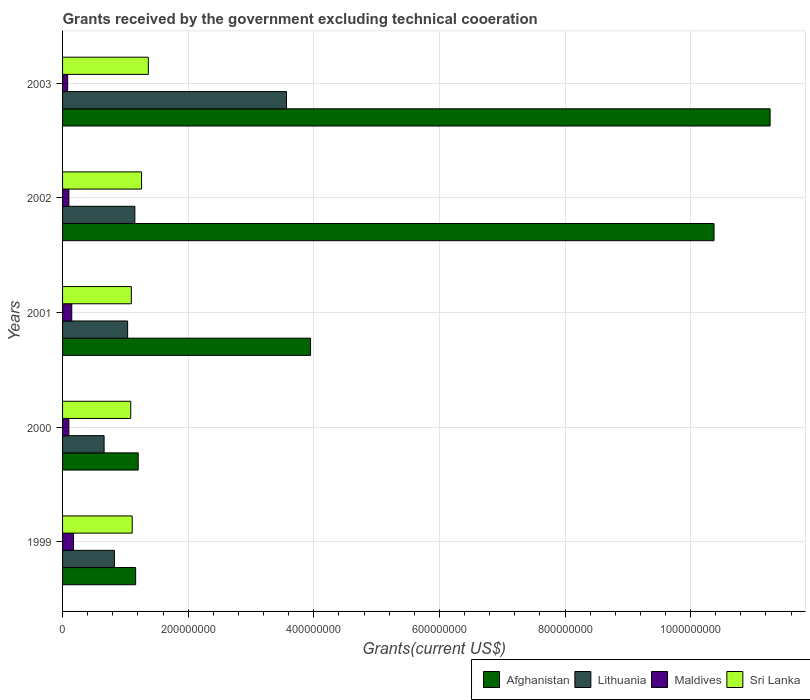Are the number of bars per tick equal to the number of legend labels?
Your response must be concise. Yes. How many bars are there on the 4th tick from the top?
Your response must be concise. 4. How many bars are there on the 3rd tick from the bottom?
Provide a succinct answer. 4. What is the label of the 1st group of bars from the top?
Your answer should be compact. 2003. In how many cases, is the number of bars for a given year not equal to the number of legend labels?
Offer a terse response. 0. What is the total grants received by the government in Sri Lanka in 2003?
Keep it short and to the point. 1.37e+08. Across all years, what is the maximum total grants received by the government in Sri Lanka?
Give a very brief answer. 1.37e+08. Across all years, what is the minimum total grants received by the government in Afghanistan?
Keep it short and to the point. 1.16e+08. What is the total total grants received by the government in Afghanistan in the graph?
Provide a succinct answer. 2.80e+09. What is the difference between the total grants received by the government in Sri Lanka in 2000 and that in 2003?
Ensure brevity in your answer.  -2.80e+07. What is the difference between the total grants received by the government in Lithuania in 2001 and the total grants received by the government in Maldives in 2002?
Keep it short and to the point. 9.35e+07. What is the average total grants received by the government in Maldives per year?
Provide a succinct answer. 1.21e+07. In the year 2003, what is the difference between the total grants received by the government in Sri Lanka and total grants received by the government in Maldives?
Keep it short and to the point. 1.28e+08. What is the ratio of the total grants received by the government in Sri Lanka in 1999 to that in 2002?
Keep it short and to the point. 0.88. What is the difference between the highest and the second highest total grants received by the government in Lithuania?
Keep it short and to the point. 2.41e+08. What is the difference between the highest and the lowest total grants received by the government in Maldives?
Your answer should be very brief. 9.37e+06. Is it the case that in every year, the sum of the total grants received by the government in Maldives and total grants received by the government in Sri Lanka is greater than the sum of total grants received by the government in Lithuania and total grants received by the government in Afghanistan?
Your answer should be very brief. Yes. What does the 4th bar from the top in 2001 represents?
Offer a terse response. Afghanistan. What does the 3rd bar from the bottom in 2003 represents?
Your response must be concise. Maldives. Is it the case that in every year, the sum of the total grants received by the government in Sri Lanka and total grants received by the government in Maldives is greater than the total grants received by the government in Afghanistan?
Offer a terse response. No. Are all the bars in the graph horizontal?
Offer a terse response. Yes. How many years are there in the graph?
Offer a terse response. 5. Are the values on the major ticks of X-axis written in scientific E-notation?
Your response must be concise. No. How are the legend labels stacked?
Provide a short and direct response. Horizontal. What is the title of the graph?
Ensure brevity in your answer.  Grants received by the government excluding technical cooeration. Does "Angola" appear as one of the legend labels in the graph?
Provide a short and direct response. No. What is the label or title of the X-axis?
Keep it short and to the point. Grants(current US$). What is the Grants(current US$) of Afghanistan in 1999?
Keep it short and to the point. 1.16e+08. What is the Grants(current US$) in Lithuania in 1999?
Ensure brevity in your answer.  8.26e+07. What is the Grants(current US$) of Maldives in 1999?
Offer a very short reply. 1.75e+07. What is the Grants(current US$) in Sri Lanka in 1999?
Keep it short and to the point. 1.11e+08. What is the Grants(current US$) in Afghanistan in 2000?
Keep it short and to the point. 1.20e+08. What is the Grants(current US$) of Lithuania in 2000?
Give a very brief answer. 6.61e+07. What is the Grants(current US$) of Maldives in 2000?
Make the answer very short. 1.00e+07. What is the Grants(current US$) in Sri Lanka in 2000?
Offer a terse response. 1.09e+08. What is the Grants(current US$) in Afghanistan in 2001?
Offer a very short reply. 3.95e+08. What is the Grants(current US$) of Lithuania in 2001?
Your answer should be compact. 1.04e+08. What is the Grants(current US$) of Maldives in 2001?
Your response must be concise. 1.46e+07. What is the Grants(current US$) in Sri Lanka in 2001?
Give a very brief answer. 1.10e+08. What is the Grants(current US$) of Afghanistan in 2002?
Provide a short and direct response. 1.04e+09. What is the Grants(current US$) in Lithuania in 2002?
Give a very brief answer. 1.15e+08. What is the Grants(current US$) of Maldives in 2002?
Your answer should be compact. 1.01e+07. What is the Grants(current US$) in Sri Lanka in 2002?
Ensure brevity in your answer.  1.26e+08. What is the Grants(current US$) in Afghanistan in 2003?
Offer a terse response. 1.13e+09. What is the Grants(current US$) in Lithuania in 2003?
Give a very brief answer. 3.57e+08. What is the Grants(current US$) in Maldives in 2003?
Offer a terse response. 8.10e+06. What is the Grants(current US$) in Sri Lanka in 2003?
Provide a short and direct response. 1.37e+08. Across all years, what is the maximum Grants(current US$) of Afghanistan?
Provide a short and direct response. 1.13e+09. Across all years, what is the maximum Grants(current US$) of Lithuania?
Your response must be concise. 3.57e+08. Across all years, what is the maximum Grants(current US$) in Maldives?
Your response must be concise. 1.75e+07. Across all years, what is the maximum Grants(current US$) in Sri Lanka?
Provide a succinct answer. 1.37e+08. Across all years, what is the minimum Grants(current US$) of Afghanistan?
Make the answer very short. 1.16e+08. Across all years, what is the minimum Grants(current US$) in Lithuania?
Make the answer very short. 6.61e+07. Across all years, what is the minimum Grants(current US$) of Maldives?
Offer a terse response. 8.10e+06. Across all years, what is the minimum Grants(current US$) of Sri Lanka?
Keep it short and to the point. 1.09e+08. What is the total Grants(current US$) of Afghanistan in the graph?
Offer a very short reply. 2.80e+09. What is the total Grants(current US$) of Lithuania in the graph?
Offer a very short reply. 7.24e+08. What is the total Grants(current US$) in Maldives in the graph?
Keep it short and to the point. 6.03e+07. What is the total Grants(current US$) in Sri Lanka in the graph?
Provide a succinct answer. 5.91e+08. What is the difference between the Grants(current US$) of Afghanistan in 1999 and that in 2000?
Make the answer very short. -4.05e+06. What is the difference between the Grants(current US$) of Lithuania in 1999 and that in 2000?
Your answer should be compact. 1.65e+07. What is the difference between the Grants(current US$) of Maldives in 1999 and that in 2000?
Provide a short and direct response. 7.45e+06. What is the difference between the Grants(current US$) in Sri Lanka in 1999 and that in 2000?
Give a very brief answer. 2.37e+06. What is the difference between the Grants(current US$) of Afghanistan in 1999 and that in 2001?
Offer a terse response. -2.78e+08. What is the difference between the Grants(current US$) of Lithuania in 1999 and that in 2001?
Provide a short and direct response. -2.10e+07. What is the difference between the Grants(current US$) in Maldives in 1999 and that in 2001?
Keep it short and to the point. 2.83e+06. What is the difference between the Grants(current US$) in Sri Lanka in 1999 and that in 2001?
Your answer should be compact. 1.39e+06. What is the difference between the Grants(current US$) of Afghanistan in 1999 and that in 2002?
Keep it short and to the point. -9.21e+08. What is the difference between the Grants(current US$) of Lithuania in 1999 and that in 2002?
Your answer should be very brief. -3.25e+07. What is the difference between the Grants(current US$) of Maldives in 1999 and that in 2002?
Keep it short and to the point. 7.39e+06. What is the difference between the Grants(current US$) of Sri Lanka in 1999 and that in 2002?
Provide a short and direct response. -1.49e+07. What is the difference between the Grants(current US$) in Afghanistan in 1999 and that in 2003?
Your response must be concise. -1.01e+09. What is the difference between the Grants(current US$) in Lithuania in 1999 and that in 2003?
Keep it short and to the point. -2.74e+08. What is the difference between the Grants(current US$) in Maldives in 1999 and that in 2003?
Give a very brief answer. 9.37e+06. What is the difference between the Grants(current US$) of Sri Lanka in 1999 and that in 2003?
Offer a very short reply. -2.56e+07. What is the difference between the Grants(current US$) in Afghanistan in 2000 and that in 2001?
Give a very brief answer. -2.74e+08. What is the difference between the Grants(current US$) in Lithuania in 2000 and that in 2001?
Keep it short and to the point. -3.75e+07. What is the difference between the Grants(current US$) in Maldives in 2000 and that in 2001?
Keep it short and to the point. -4.62e+06. What is the difference between the Grants(current US$) of Sri Lanka in 2000 and that in 2001?
Offer a very short reply. -9.80e+05. What is the difference between the Grants(current US$) in Afghanistan in 2000 and that in 2002?
Your answer should be compact. -9.17e+08. What is the difference between the Grants(current US$) in Lithuania in 2000 and that in 2002?
Your answer should be compact. -4.90e+07. What is the difference between the Grants(current US$) in Sri Lanka in 2000 and that in 2002?
Offer a very short reply. -1.72e+07. What is the difference between the Grants(current US$) in Afghanistan in 2000 and that in 2003?
Ensure brevity in your answer.  -1.01e+09. What is the difference between the Grants(current US$) in Lithuania in 2000 and that in 2003?
Your answer should be compact. -2.90e+08. What is the difference between the Grants(current US$) of Maldives in 2000 and that in 2003?
Keep it short and to the point. 1.92e+06. What is the difference between the Grants(current US$) of Sri Lanka in 2000 and that in 2003?
Ensure brevity in your answer.  -2.80e+07. What is the difference between the Grants(current US$) in Afghanistan in 2001 and that in 2002?
Ensure brevity in your answer.  -6.42e+08. What is the difference between the Grants(current US$) of Lithuania in 2001 and that in 2002?
Make the answer very short. -1.15e+07. What is the difference between the Grants(current US$) in Maldives in 2001 and that in 2002?
Keep it short and to the point. 4.56e+06. What is the difference between the Grants(current US$) in Sri Lanka in 2001 and that in 2002?
Make the answer very short. -1.63e+07. What is the difference between the Grants(current US$) of Afghanistan in 2001 and that in 2003?
Provide a succinct answer. -7.32e+08. What is the difference between the Grants(current US$) of Lithuania in 2001 and that in 2003?
Your answer should be very brief. -2.53e+08. What is the difference between the Grants(current US$) in Maldives in 2001 and that in 2003?
Your answer should be compact. 6.54e+06. What is the difference between the Grants(current US$) in Sri Lanka in 2001 and that in 2003?
Your answer should be very brief. -2.70e+07. What is the difference between the Grants(current US$) in Afghanistan in 2002 and that in 2003?
Offer a very short reply. -8.93e+07. What is the difference between the Grants(current US$) in Lithuania in 2002 and that in 2003?
Make the answer very short. -2.41e+08. What is the difference between the Grants(current US$) in Maldives in 2002 and that in 2003?
Keep it short and to the point. 1.98e+06. What is the difference between the Grants(current US$) in Sri Lanka in 2002 and that in 2003?
Your response must be concise. -1.08e+07. What is the difference between the Grants(current US$) of Afghanistan in 1999 and the Grants(current US$) of Lithuania in 2000?
Your response must be concise. 5.03e+07. What is the difference between the Grants(current US$) of Afghanistan in 1999 and the Grants(current US$) of Maldives in 2000?
Provide a succinct answer. 1.06e+08. What is the difference between the Grants(current US$) of Afghanistan in 1999 and the Grants(current US$) of Sri Lanka in 2000?
Make the answer very short. 7.83e+06. What is the difference between the Grants(current US$) of Lithuania in 1999 and the Grants(current US$) of Maldives in 2000?
Your answer should be very brief. 7.26e+07. What is the difference between the Grants(current US$) in Lithuania in 1999 and the Grants(current US$) in Sri Lanka in 2000?
Your answer should be very brief. -2.60e+07. What is the difference between the Grants(current US$) of Maldives in 1999 and the Grants(current US$) of Sri Lanka in 2000?
Your answer should be compact. -9.11e+07. What is the difference between the Grants(current US$) in Afghanistan in 1999 and the Grants(current US$) in Lithuania in 2001?
Your response must be concise. 1.28e+07. What is the difference between the Grants(current US$) of Afghanistan in 1999 and the Grants(current US$) of Maldives in 2001?
Your answer should be compact. 1.02e+08. What is the difference between the Grants(current US$) of Afghanistan in 1999 and the Grants(current US$) of Sri Lanka in 2001?
Give a very brief answer. 6.85e+06. What is the difference between the Grants(current US$) of Lithuania in 1999 and the Grants(current US$) of Maldives in 2001?
Provide a succinct answer. 6.79e+07. What is the difference between the Grants(current US$) in Lithuania in 1999 and the Grants(current US$) in Sri Lanka in 2001?
Provide a short and direct response. -2.70e+07. What is the difference between the Grants(current US$) of Maldives in 1999 and the Grants(current US$) of Sri Lanka in 2001?
Provide a succinct answer. -9.20e+07. What is the difference between the Grants(current US$) of Afghanistan in 1999 and the Grants(current US$) of Lithuania in 2002?
Keep it short and to the point. 1.28e+06. What is the difference between the Grants(current US$) of Afghanistan in 1999 and the Grants(current US$) of Maldives in 2002?
Your response must be concise. 1.06e+08. What is the difference between the Grants(current US$) of Afghanistan in 1999 and the Grants(current US$) of Sri Lanka in 2002?
Your answer should be compact. -9.41e+06. What is the difference between the Grants(current US$) in Lithuania in 1999 and the Grants(current US$) in Maldives in 2002?
Provide a succinct answer. 7.25e+07. What is the difference between the Grants(current US$) in Lithuania in 1999 and the Grants(current US$) in Sri Lanka in 2002?
Offer a very short reply. -4.32e+07. What is the difference between the Grants(current US$) of Maldives in 1999 and the Grants(current US$) of Sri Lanka in 2002?
Give a very brief answer. -1.08e+08. What is the difference between the Grants(current US$) in Afghanistan in 1999 and the Grants(current US$) in Lithuania in 2003?
Make the answer very short. -2.40e+08. What is the difference between the Grants(current US$) in Afghanistan in 1999 and the Grants(current US$) in Maldives in 2003?
Your answer should be very brief. 1.08e+08. What is the difference between the Grants(current US$) of Afghanistan in 1999 and the Grants(current US$) of Sri Lanka in 2003?
Ensure brevity in your answer.  -2.02e+07. What is the difference between the Grants(current US$) in Lithuania in 1999 and the Grants(current US$) in Maldives in 2003?
Ensure brevity in your answer.  7.45e+07. What is the difference between the Grants(current US$) in Lithuania in 1999 and the Grants(current US$) in Sri Lanka in 2003?
Your response must be concise. -5.40e+07. What is the difference between the Grants(current US$) in Maldives in 1999 and the Grants(current US$) in Sri Lanka in 2003?
Provide a succinct answer. -1.19e+08. What is the difference between the Grants(current US$) in Afghanistan in 2000 and the Grants(current US$) in Lithuania in 2001?
Ensure brevity in your answer.  1.68e+07. What is the difference between the Grants(current US$) of Afghanistan in 2000 and the Grants(current US$) of Maldives in 2001?
Make the answer very short. 1.06e+08. What is the difference between the Grants(current US$) in Afghanistan in 2000 and the Grants(current US$) in Sri Lanka in 2001?
Provide a short and direct response. 1.09e+07. What is the difference between the Grants(current US$) in Lithuania in 2000 and the Grants(current US$) in Maldives in 2001?
Make the answer very short. 5.15e+07. What is the difference between the Grants(current US$) in Lithuania in 2000 and the Grants(current US$) in Sri Lanka in 2001?
Your answer should be very brief. -4.34e+07. What is the difference between the Grants(current US$) in Maldives in 2000 and the Grants(current US$) in Sri Lanka in 2001?
Your response must be concise. -9.95e+07. What is the difference between the Grants(current US$) of Afghanistan in 2000 and the Grants(current US$) of Lithuania in 2002?
Offer a very short reply. 5.33e+06. What is the difference between the Grants(current US$) in Afghanistan in 2000 and the Grants(current US$) in Maldives in 2002?
Provide a succinct answer. 1.10e+08. What is the difference between the Grants(current US$) in Afghanistan in 2000 and the Grants(current US$) in Sri Lanka in 2002?
Provide a short and direct response. -5.36e+06. What is the difference between the Grants(current US$) in Lithuania in 2000 and the Grants(current US$) in Maldives in 2002?
Your answer should be very brief. 5.60e+07. What is the difference between the Grants(current US$) of Lithuania in 2000 and the Grants(current US$) of Sri Lanka in 2002?
Provide a short and direct response. -5.97e+07. What is the difference between the Grants(current US$) in Maldives in 2000 and the Grants(current US$) in Sri Lanka in 2002?
Make the answer very short. -1.16e+08. What is the difference between the Grants(current US$) of Afghanistan in 2000 and the Grants(current US$) of Lithuania in 2003?
Your response must be concise. -2.36e+08. What is the difference between the Grants(current US$) in Afghanistan in 2000 and the Grants(current US$) in Maldives in 2003?
Make the answer very short. 1.12e+08. What is the difference between the Grants(current US$) of Afghanistan in 2000 and the Grants(current US$) of Sri Lanka in 2003?
Ensure brevity in your answer.  -1.61e+07. What is the difference between the Grants(current US$) of Lithuania in 2000 and the Grants(current US$) of Maldives in 2003?
Your answer should be very brief. 5.80e+07. What is the difference between the Grants(current US$) in Lithuania in 2000 and the Grants(current US$) in Sri Lanka in 2003?
Offer a terse response. -7.04e+07. What is the difference between the Grants(current US$) in Maldives in 2000 and the Grants(current US$) in Sri Lanka in 2003?
Provide a short and direct response. -1.27e+08. What is the difference between the Grants(current US$) of Afghanistan in 2001 and the Grants(current US$) of Lithuania in 2002?
Your response must be concise. 2.80e+08. What is the difference between the Grants(current US$) in Afghanistan in 2001 and the Grants(current US$) in Maldives in 2002?
Ensure brevity in your answer.  3.85e+08. What is the difference between the Grants(current US$) in Afghanistan in 2001 and the Grants(current US$) in Sri Lanka in 2002?
Keep it short and to the point. 2.69e+08. What is the difference between the Grants(current US$) in Lithuania in 2001 and the Grants(current US$) in Maldives in 2002?
Ensure brevity in your answer.  9.35e+07. What is the difference between the Grants(current US$) in Lithuania in 2001 and the Grants(current US$) in Sri Lanka in 2002?
Provide a short and direct response. -2.22e+07. What is the difference between the Grants(current US$) in Maldives in 2001 and the Grants(current US$) in Sri Lanka in 2002?
Make the answer very short. -1.11e+08. What is the difference between the Grants(current US$) in Afghanistan in 2001 and the Grants(current US$) in Lithuania in 2003?
Offer a very short reply. 3.83e+07. What is the difference between the Grants(current US$) in Afghanistan in 2001 and the Grants(current US$) in Maldives in 2003?
Offer a terse response. 3.87e+08. What is the difference between the Grants(current US$) in Afghanistan in 2001 and the Grants(current US$) in Sri Lanka in 2003?
Offer a terse response. 2.58e+08. What is the difference between the Grants(current US$) of Lithuania in 2001 and the Grants(current US$) of Maldives in 2003?
Give a very brief answer. 9.55e+07. What is the difference between the Grants(current US$) in Lithuania in 2001 and the Grants(current US$) in Sri Lanka in 2003?
Your answer should be very brief. -3.29e+07. What is the difference between the Grants(current US$) in Maldives in 2001 and the Grants(current US$) in Sri Lanka in 2003?
Offer a very short reply. -1.22e+08. What is the difference between the Grants(current US$) of Afghanistan in 2002 and the Grants(current US$) of Lithuania in 2003?
Your response must be concise. 6.81e+08. What is the difference between the Grants(current US$) in Afghanistan in 2002 and the Grants(current US$) in Maldives in 2003?
Offer a terse response. 1.03e+09. What is the difference between the Grants(current US$) of Afghanistan in 2002 and the Grants(current US$) of Sri Lanka in 2003?
Provide a succinct answer. 9.01e+08. What is the difference between the Grants(current US$) in Lithuania in 2002 and the Grants(current US$) in Maldives in 2003?
Provide a succinct answer. 1.07e+08. What is the difference between the Grants(current US$) in Lithuania in 2002 and the Grants(current US$) in Sri Lanka in 2003?
Your answer should be compact. -2.15e+07. What is the difference between the Grants(current US$) in Maldives in 2002 and the Grants(current US$) in Sri Lanka in 2003?
Give a very brief answer. -1.26e+08. What is the average Grants(current US$) of Afghanistan per year?
Give a very brief answer. 5.59e+08. What is the average Grants(current US$) in Lithuania per year?
Your answer should be compact. 1.45e+08. What is the average Grants(current US$) of Maldives per year?
Make the answer very short. 1.21e+07. What is the average Grants(current US$) in Sri Lanka per year?
Provide a short and direct response. 1.18e+08. In the year 1999, what is the difference between the Grants(current US$) in Afghanistan and Grants(current US$) in Lithuania?
Provide a succinct answer. 3.38e+07. In the year 1999, what is the difference between the Grants(current US$) in Afghanistan and Grants(current US$) in Maldives?
Provide a succinct answer. 9.89e+07. In the year 1999, what is the difference between the Grants(current US$) of Afghanistan and Grants(current US$) of Sri Lanka?
Your answer should be very brief. 5.46e+06. In the year 1999, what is the difference between the Grants(current US$) in Lithuania and Grants(current US$) in Maldives?
Keep it short and to the point. 6.51e+07. In the year 1999, what is the difference between the Grants(current US$) in Lithuania and Grants(current US$) in Sri Lanka?
Make the answer very short. -2.83e+07. In the year 1999, what is the difference between the Grants(current US$) of Maldives and Grants(current US$) of Sri Lanka?
Make the answer very short. -9.34e+07. In the year 2000, what is the difference between the Grants(current US$) in Afghanistan and Grants(current US$) in Lithuania?
Provide a succinct answer. 5.43e+07. In the year 2000, what is the difference between the Grants(current US$) of Afghanistan and Grants(current US$) of Maldives?
Your answer should be compact. 1.10e+08. In the year 2000, what is the difference between the Grants(current US$) in Afghanistan and Grants(current US$) in Sri Lanka?
Offer a terse response. 1.19e+07. In the year 2000, what is the difference between the Grants(current US$) of Lithuania and Grants(current US$) of Maldives?
Your response must be concise. 5.61e+07. In the year 2000, what is the difference between the Grants(current US$) in Lithuania and Grants(current US$) in Sri Lanka?
Make the answer very short. -4.24e+07. In the year 2000, what is the difference between the Grants(current US$) in Maldives and Grants(current US$) in Sri Lanka?
Your response must be concise. -9.85e+07. In the year 2001, what is the difference between the Grants(current US$) of Afghanistan and Grants(current US$) of Lithuania?
Your response must be concise. 2.91e+08. In the year 2001, what is the difference between the Grants(current US$) of Afghanistan and Grants(current US$) of Maldives?
Ensure brevity in your answer.  3.80e+08. In the year 2001, what is the difference between the Grants(current US$) in Afghanistan and Grants(current US$) in Sri Lanka?
Keep it short and to the point. 2.85e+08. In the year 2001, what is the difference between the Grants(current US$) in Lithuania and Grants(current US$) in Maldives?
Give a very brief answer. 8.90e+07. In the year 2001, what is the difference between the Grants(current US$) in Lithuania and Grants(current US$) in Sri Lanka?
Your answer should be compact. -5.90e+06. In the year 2001, what is the difference between the Grants(current US$) of Maldives and Grants(current US$) of Sri Lanka?
Offer a very short reply. -9.49e+07. In the year 2002, what is the difference between the Grants(current US$) in Afghanistan and Grants(current US$) in Lithuania?
Keep it short and to the point. 9.22e+08. In the year 2002, what is the difference between the Grants(current US$) in Afghanistan and Grants(current US$) in Maldives?
Keep it short and to the point. 1.03e+09. In the year 2002, what is the difference between the Grants(current US$) in Afghanistan and Grants(current US$) in Sri Lanka?
Provide a succinct answer. 9.11e+08. In the year 2002, what is the difference between the Grants(current US$) in Lithuania and Grants(current US$) in Maldives?
Your response must be concise. 1.05e+08. In the year 2002, what is the difference between the Grants(current US$) in Lithuania and Grants(current US$) in Sri Lanka?
Make the answer very short. -1.07e+07. In the year 2002, what is the difference between the Grants(current US$) in Maldives and Grants(current US$) in Sri Lanka?
Ensure brevity in your answer.  -1.16e+08. In the year 2003, what is the difference between the Grants(current US$) of Afghanistan and Grants(current US$) of Lithuania?
Your answer should be very brief. 7.70e+08. In the year 2003, what is the difference between the Grants(current US$) of Afghanistan and Grants(current US$) of Maldives?
Make the answer very short. 1.12e+09. In the year 2003, what is the difference between the Grants(current US$) of Afghanistan and Grants(current US$) of Sri Lanka?
Make the answer very short. 9.90e+08. In the year 2003, what is the difference between the Grants(current US$) in Lithuania and Grants(current US$) in Maldives?
Your response must be concise. 3.48e+08. In the year 2003, what is the difference between the Grants(current US$) in Lithuania and Grants(current US$) in Sri Lanka?
Offer a terse response. 2.20e+08. In the year 2003, what is the difference between the Grants(current US$) in Maldives and Grants(current US$) in Sri Lanka?
Provide a short and direct response. -1.28e+08. What is the ratio of the Grants(current US$) in Afghanistan in 1999 to that in 2000?
Keep it short and to the point. 0.97. What is the ratio of the Grants(current US$) of Lithuania in 1999 to that in 2000?
Your answer should be compact. 1.25. What is the ratio of the Grants(current US$) of Maldives in 1999 to that in 2000?
Provide a short and direct response. 1.74. What is the ratio of the Grants(current US$) of Sri Lanka in 1999 to that in 2000?
Provide a succinct answer. 1.02. What is the ratio of the Grants(current US$) in Afghanistan in 1999 to that in 2001?
Ensure brevity in your answer.  0.29. What is the ratio of the Grants(current US$) in Lithuania in 1999 to that in 2001?
Offer a very short reply. 0.8. What is the ratio of the Grants(current US$) of Maldives in 1999 to that in 2001?
Ensure brevity in your answer.  1.19. What is the ratio of the Grants(current US$) in Sri Lanka in 1999 to that in 2001?
Offer a very short reply. 1.01. What is the ratio of the Grants(current US$) in Afghanistan in 1999 to that in 2002?
Give a very brief answer. 0.11. What is the ratio of the Grants(current US$) of Lithuania in 1999 to that in 2002?
Your answer should be very brief. 0.72. What is the ratio of the Grants(current US$) in Maldives in 1999 to that in 2002?
Your answer should be compact. 1.73. What is the ratio of the Grants(current US$) of Sri Lanka in 1999 to that in 2002?
Ensure brevity in your answer.  0.88. What is the ratio of the Grants(current US$) of Afghanistan in 1999 to that in 2003?
Give a very brief answer. 0.1. What is the ratio of the Grants(current US$) in Lithuania in 1999 to that in 2003?
Your answer should be very brief. 0.23. What is the ratio of the Grants(current US$) of Maldives in 1999 to that in 2003?
Offer a terse response. 2.16. What is the ratio of the Grants(current US$) in Sri Lanka in 1999 to that in 2003?
Offer a very short reply. 0.81. What is the ratio of the Grants(current US$) in Afghanistan in 2000 to that in 2001?
Give a very brief answer. 0.3. What is the ratio of the Grants(current US$) in Lithuania in 2000 to that in 2001?
Offer a very short reply. 0.64. What is the ratio of the Grants(current US$) in Maldives in 2000 to that in 2001?
Offer a terse response. 0.68. What is the ratio of the Grants(current US$) of Afghanistan in 2000 to that in 2002?
Provide a succinct answer. 0.12. What is the ratio of the Grants(current US$) in Lithuania in 2000 to that in 2002?
Provide a succinct answer. 0.57. What is the ratio of the Grants(current US$) in Sri Lanka in 2000 to that in 2002?
Your response must be concise. 0.86. What is the ratio of the Grants(current US$) of Afghanistan in 2000 to that in 2003?
Your answer should be very brief. 0.11. What is the ratio of the Grants(current US$) of Lithuania in 2000 to that in 2003?
Provide a short and direct response. 0.19. What is the ratio of the Grants(current US$) of Maldives in 2000 to that in 2003?
Offer a very short reply. 1.24. What is the ratio of the Grants(current US$) of Sri Lanka in 2000 to that in 2003?
Provide a succinct answer. 0.79. What is the ratio of the Grants(current US$) of Afghanistan in 2001 to that in 2002?
Give a very brief answer. 0.38. What is the ratio of the Grants(current US$) of Lithuania in 2001 to that in 2002?
Offer a very short reply. 0.9. What is the ratio of the Grants(current US$) of Maldives in 2001 to that in 2002?
Your response must be concise. 1.45. What is the ratio of the Grants(current US$) in Sri Lanka in 2001 to that in 2002?
Keep it short and to the point. 0.87. What is the ratio of the Grants(current US$) in Afghanistan in 2001 to that in 2003?
Provide a succinct answer. 0.35. What is the ratio of the Grants(current US$) of Lithuania in 2001 to that in 2003?
Provide a succinct answer. 0.29. What is the ratio of the Grants(current US$) of Maldives in 2001 to that in 2003?
Your answer should be compact. 1.81. What is the ratio of the Grants(current US$) of Sri Lanka in 2001 to that in 2003?
Offer a terse response. 0.8. What is the ratio of the Grants(current US$) of Afghanistan in 2002 to that in 2003?
Provide a succinct answer. 0.92. What is the ratio of the Grants(current US$) of Lithuania in 2002 to that in 2003?
Your answer should be very brief. 0.32. What is the ratio of the Grants(current US$) in Maldives in 2002 to that in 2003?
Make the answer very short. 1.24. What is the ratio of the Grants(current US$) in Sri Lanka in 2002 to that in 2003?
Make the answer very short. 0.92. What is the difference between the highest and the second highest Grants(current US$) of Afghanistan?
Provide a short and direct response. 8.93e+07. What is the difference between the highest and the second highest Grants(current US$) in Lithuania?
Provide a short and direct response. 2.41e+08. What is the difference between the highest and the second highest Grants(current US$) in Maldives?
Offer a very short reply. 2.83e+06. What is the difference between the highest and the second highest Grants(current US$) of Sri Lanka?
Your answer should be very brief. 1.08e+07. What is the difference between the highest and the lowest Grants(current US$) of Afghanistan?
Offer a very short reply. 1.01e+09. What is the difference between the highest and the lowest Grants(current US$) in Lithuania?
Your answer should be compact. 2.90e+08. What is the difference between the highest and the lowest Grants(current US$) in Maldives?
Your answer should be very brief. 9.37e+06. What is the difference between the highest and the lowest Grants(current US$) of Sri Lanka?
Offer a terse response. 2.80e+07. 